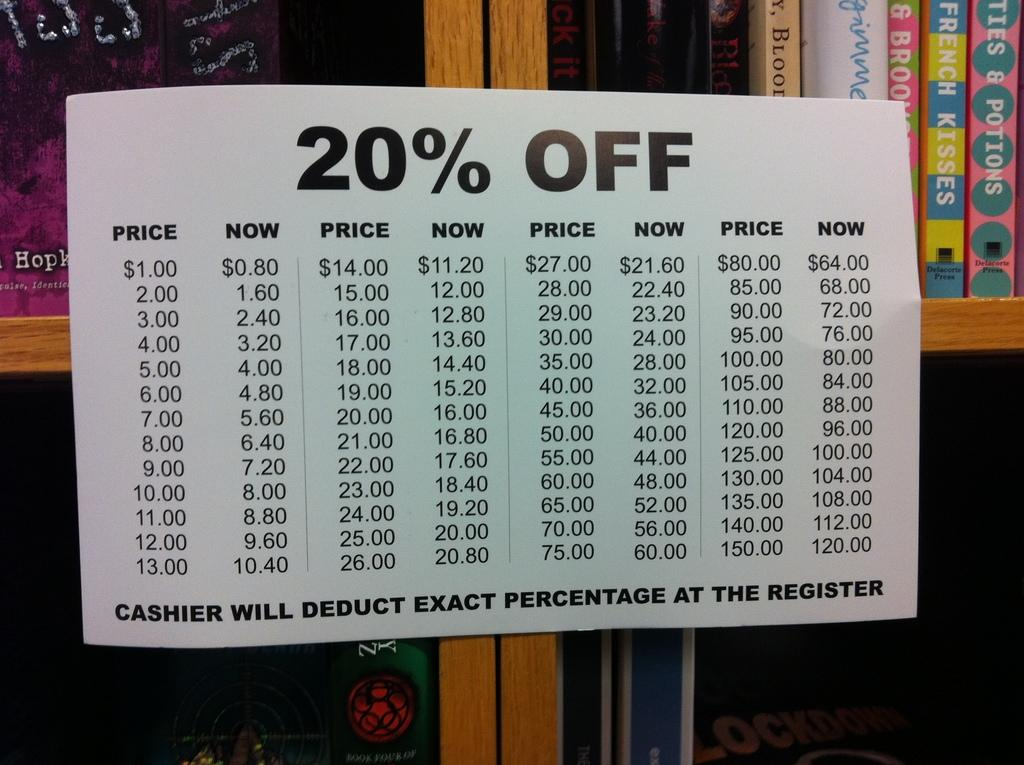<image>
Relay a brief, clear account of the picture shown. A chart telling the customer how to apply the 20% off discount. 